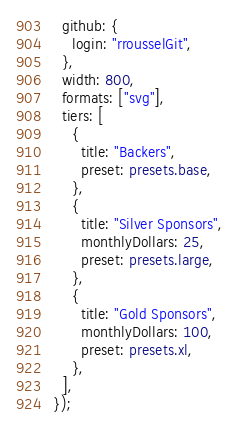<code> <loc_0><loc_0><loc_500><loc_500><_TypeScript_>  github: {
    login: "rrousselGit",
  },
  width: 800,
  formats: ["svg"],
  tiers: [
    {
      title: "Backers",
      preset: presets.base,
    },
    {
      title: "Silver Sponsors",
      monthlyDollars: 25,
      preset: presets.large,
    },
    {
      title: "Gold Sponsors",
      monthlyDollars: 100,
      preset: presets.xl,
    },
  ],
});
</code> 